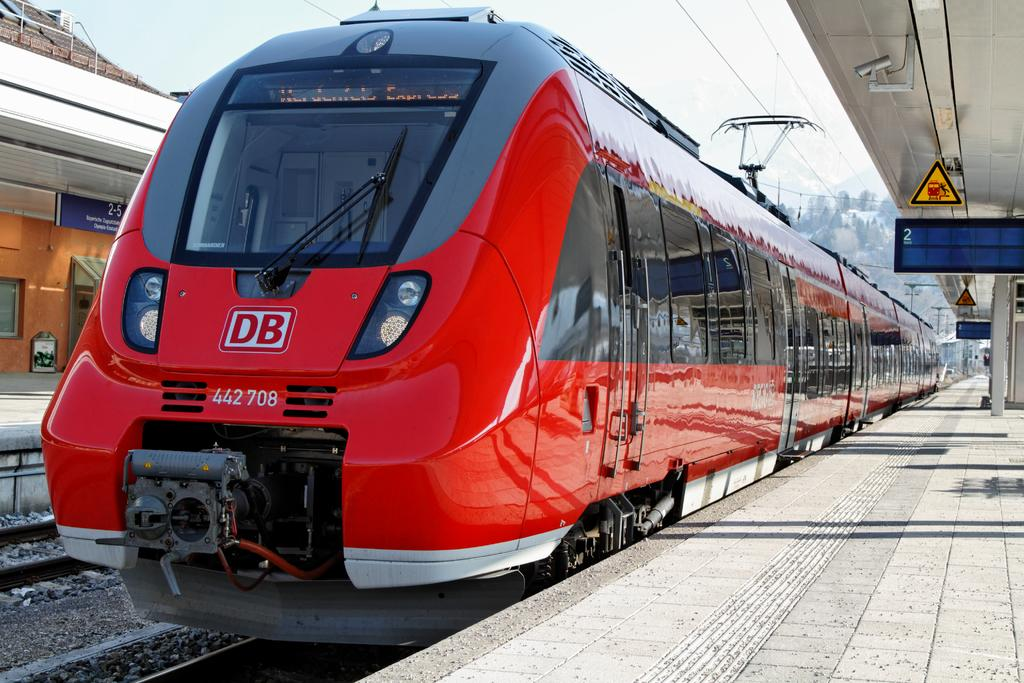<image>
Share a concise interpretation of the image provided. A red train with the letters DB on the front 